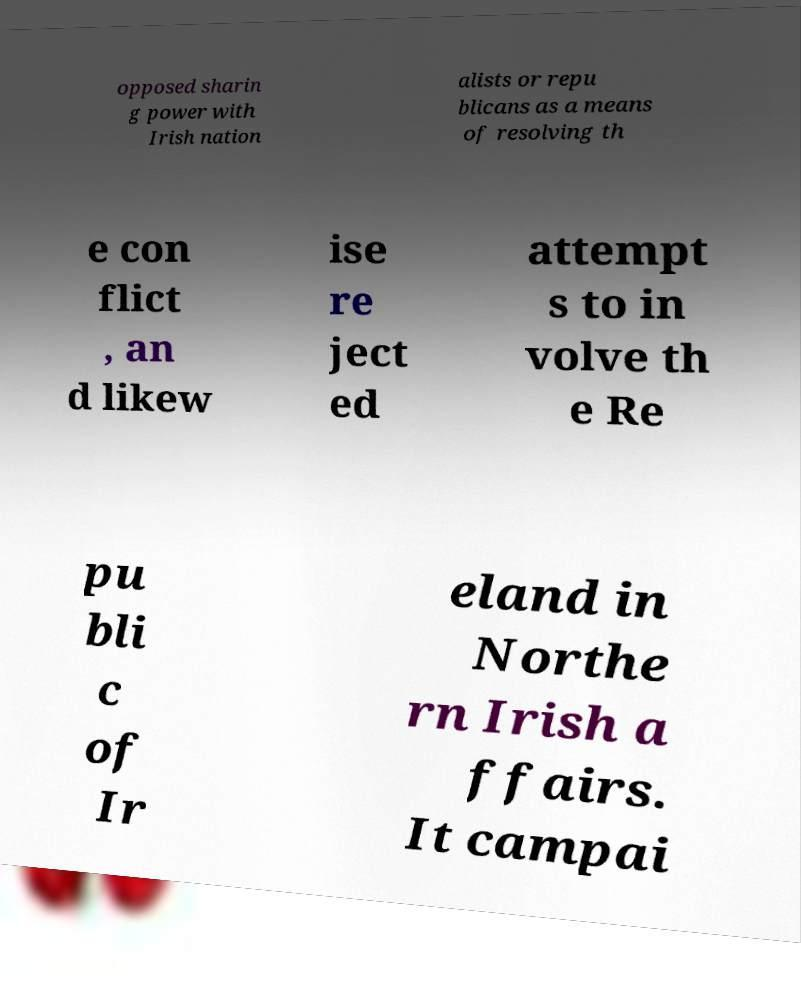Can you read and provide the text displayed in the image?This photo seems to have some interesting text. Can you extract and type it out for me? opposed sharin g power with Irish nation alists or repu blicans as a means of resolving th e con flict , an d likew ise re ject ed attempt s to in volve th e Re pu bli c of Ir eland in Northe rn Irish a ffairs. It campai 